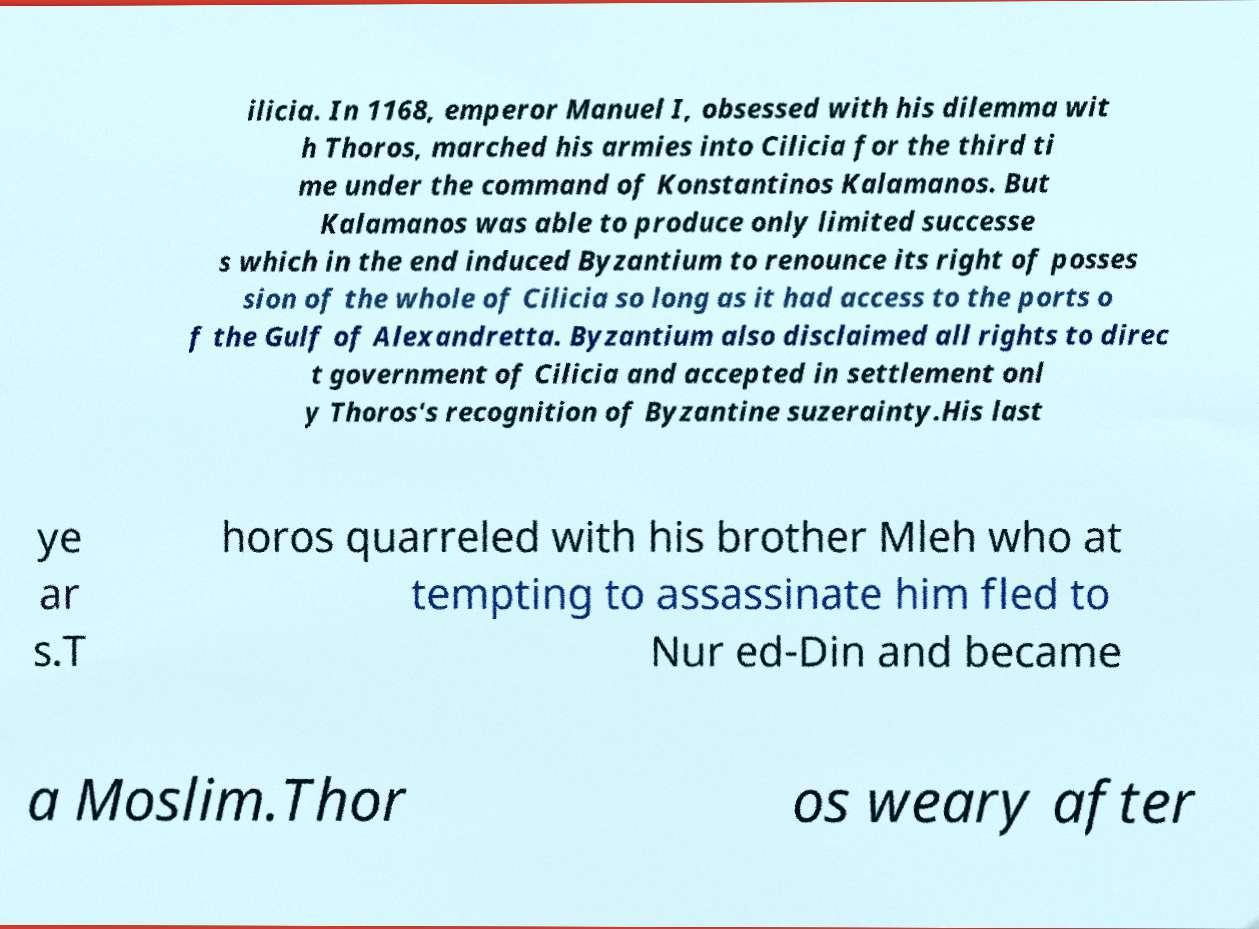Please identify and transcribe the text found in this image. ilicia. In 1168, emperor Manuel I, obsessed with his dilemma wit h Thoros, marched his armies into Cilicia for the third ti me under the command of Konstantinos Kalamanos. But Kalamanos was able to produce only limited successe s which in the end induced Byzantium to renounce its right of posses sion of the whole of Cilicia so long as it had access to the ports o f the Gulf of Alexandretta. Byzantium also disclaimed all rights to direc t government of Cilicia and accepted in settlement onl y Thoros's recognition of Byzantine suzerainty.His last ye ar s.T horos quarreled with his brother Mleh who at tempting to assassinate him fled to Nur ed-Din and became a Moslim.Thor os weary after 